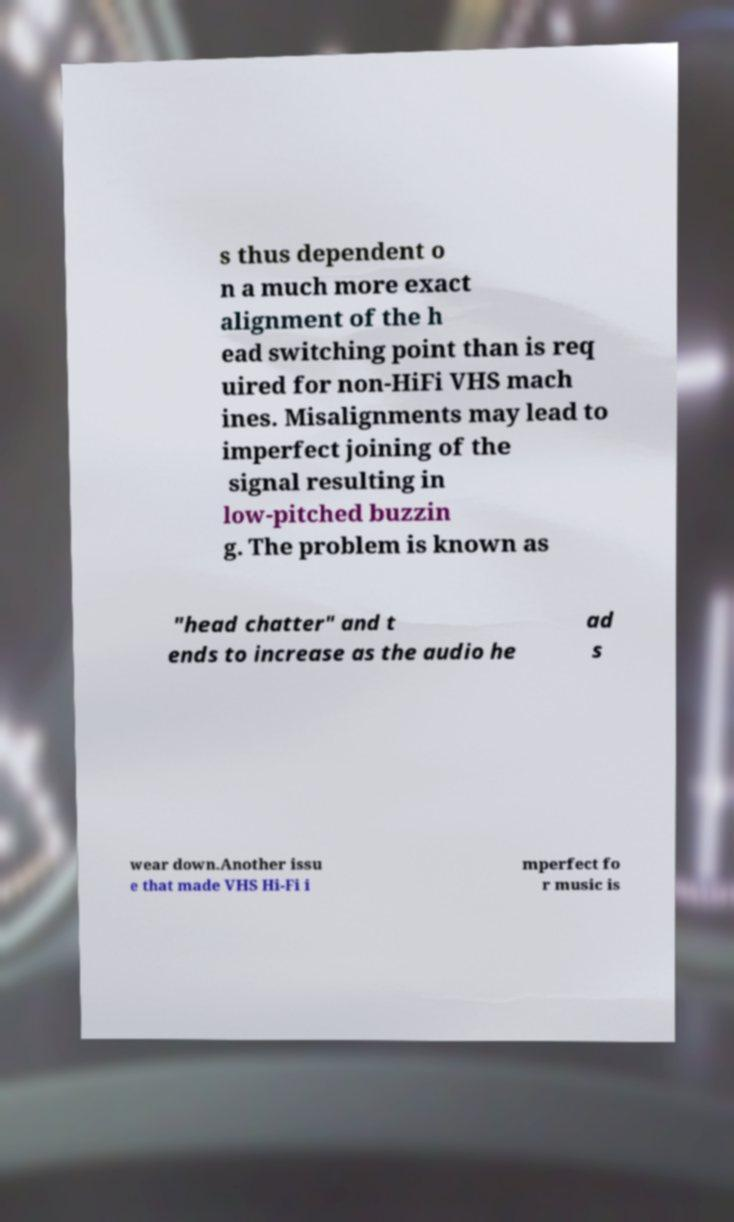Please read and relay the text visible in this image. What does it say? s thus dependent o n a much more exact alignment of the h ead switching point than is req uired for non-HiFi VHS mach ines. Misalignments may lead to imperfect joining of the signal resulting in low-pitched buzzin g. The problem is known as "head chatter" and t ends to increase as the audio he ad s wear down.Another issu e that made VHS Hi-Fi i mperfect fo r music is 